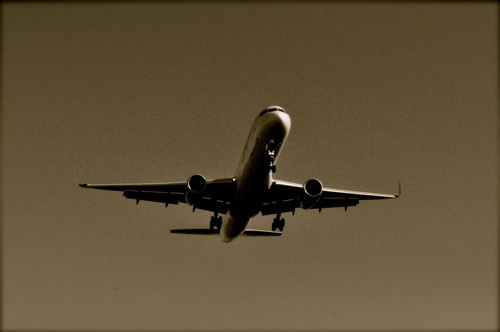Describe the objects in this image and their specific colors. I can see a airplane in black and gray tones in this image. 